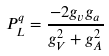Convert formula to latex. <formula><loc_0><loc_0><loc_500><loc_500>P ^ { q } _ { L } = { \frac { - 2 g _ { v } g _ { a } } { g ^ { 2 } _ { V } + g ^ { 2 } _ { A } } }</formula> 